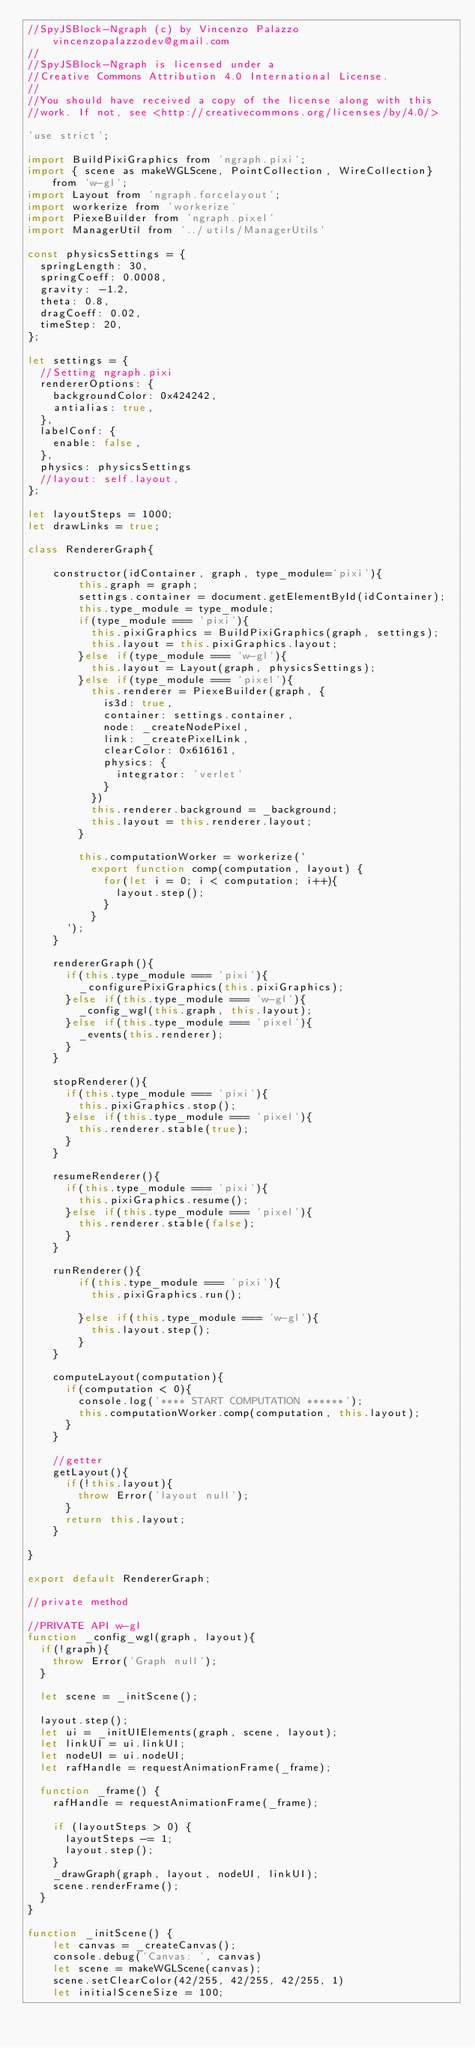Convert code to text. <code><loc_0><loc_0><loc_500><loc_500><_JavaScript_>//SpyJSBlock-Ngraph (c) by Vincenzo Palazzo vincenzopalazzodev@gmail.com
//
//SpyJSBlock-Ngraph is licensed under a
//Creative Commons Attribution 4.0 International License.
//
//You should have received a copy of the license along with this
//work. If not, see <http://creativecommons.org/licenses/by/4.0/>

'use strict';

import BuildPixiGraphics from 'ngraph.pixi';
import { scene as makeWGLScene, PointCollection, WireCollection} from 'w-gl';
import Layout from 'ngraph.forcelayout';
import workerize from 'workerize'
import PiexeBuilder from 'ngraph.pixel'
import ManagerUtil from '../utils/ManagerUtils'

const physicsSettings = {
  springLength: 30,
  springCoeff: 0.0008,
  gravity: -1.2,
  theta: 0.8,
  dragCoeff: 0.02,
  timeStep: 20,
};

let settings = {
  //Setting ngraph.pixi
  rendererOptions: {
    backgroundColor: 0x424242,
    antialias: true,
  },
  labelConf: {
    enable: false,
  },
  physics: physicsSettings
  //layout: self.layout,
};

let layoutSteps = 1000;
let drawLinks = true;

class RendererGraph{

    constructor(idContainer, graph, type_module='pixi'){
        this.graph = graph;
        settings.container = document.getElementById(idContainer);
        this.type_module = type_module;
        if(type_module === 'pixi'){
          this.pixiGraphics = BuildPixiGraphics(graph, settings);
          this.layout = this.pixiGraphics.layout;
        }else if(type_module === 'w-gl'){
          this.layout = Layout(graph, physicsSettings);
        }else if(type_module === 'pixel'){
          this.renderer = PiexeBuilder(graph, {
            is3d: true,
            container: settings.container,
            node: _createNodePixel,
            link: _createPixelLink,
            clearColor: 0x616161,
            physics: {
              integrator: 'verlet'
            }
          })
          this.renderer.background = _background;
          this.layout = this.renderer.layout;
        }

        this.computationWorker = workerize(`
          export function comp(computation, layout) {
            for(let i = 0; i < computation; i++){
              layout.step();
            }
          }
      `);
    }

    rendererGraph(){
      if(this.type_module === 'pixi'){
        _configurePixiGraphics(this.pixiGraphics);
      }else if(this.type_module === 'w-gl'){
        _config_wgl(this.graph, this.layout);
      }else if(this.type_module === 'pixel'){
        _events(this.renderer);
      }
    }

    stopRenderer(){
      if(this.type_module === 'pixi'){
        this.pixiGraphics.stop();
      }else if(this.type_module === 'pixel'){
        this.renderer.stable(true);
      }
    }

    resumeRenderer(){
      if(this.type_module === 'pixi'){
        this.pixiGraphics.resume();
      }else if(this.type_module === 'pixel'){
        this.renderer.stable(false);
      }
    }

    runRenderer(){
        if(this.type_module === 'pixi'){
          this.pixiGraphics.run();
          
        }else if(this.type_module === 'w-gl'){
          this.layout.step();
        }
    }

    computeLayout(computation){
      if(computation < 0){
        console.log('**** START COMPUTATION ******');
        this.computationWorker.comp(computation, this.layout);
      }
    }

    //getter
    getLayout(){
      if(!this.layout){
        throw Error('layout null');
      }
      return this.layout;
    }

}

export default RendererGraph;

//private method

//PRIVATE API w-gl
function _config_wgl(graph, layout){
  if(!graph){
    throw Error('Graph null');
  }

  let scene = _initScene();

  layout.step();
  let ui = _initUIElements(graph, scene, layout);
  let linkUI = ui.linkUI;
  let nodeUI = ui.nodeUI;
  let rafHandle = requestAnimationFrame(_frame);

  function _frame() {
    rafHandle = requestAnimationFrame(_frame);

    if (layoutSteps > 0) {
      layoutSteps -= 1;
      layout.step();
    }
    _drawGraph(graph, layout, nodeUI, linkUI);
    scene.renderFrame();
  }
}

function _initScene() {
    let canvas = _createCanvas();
    console.debug('Canvas: ', canvas)
    let scene = makeWGLScene(canvas);
    scene.setClearColor(42/255, 42/255, 42/255, 1)
    let initialSceneSize = 100;</code> 